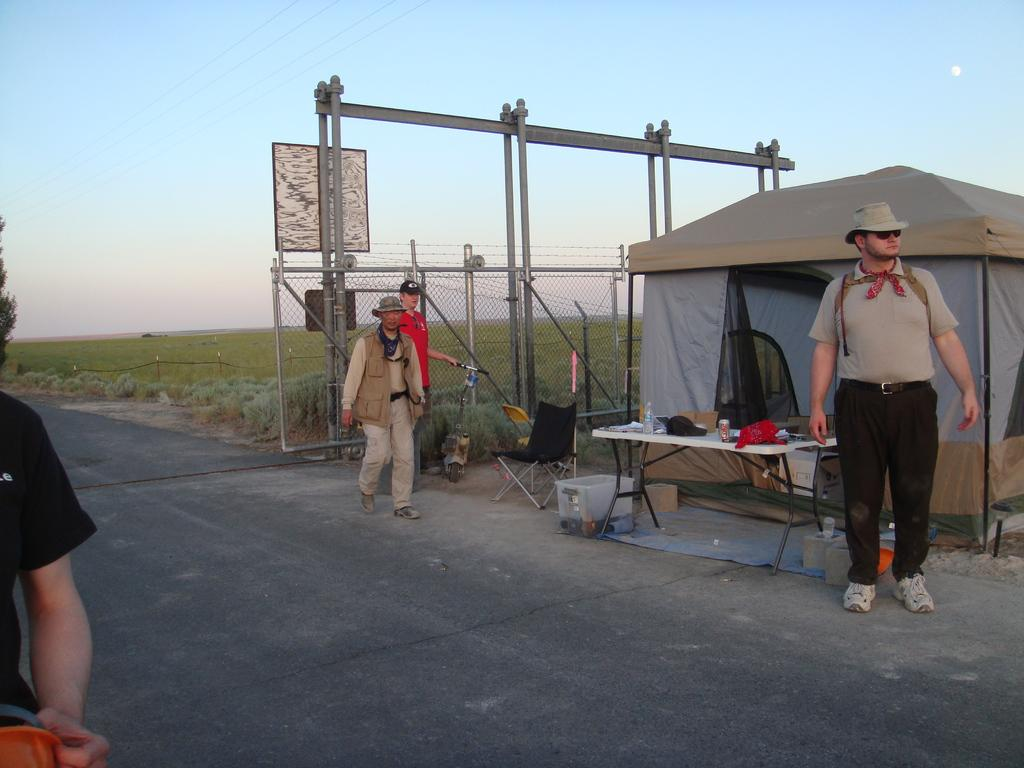What are the people in the image doing? The persons in the image are standing on the road. What can be seen in the background of the image? In the background, there is a tent, a table, a water bottle, fencing, plants, a tree, and the sky. How many objects can be seen in the background? There are eight objects visible in the background: a tent, a table, a water bottle, fencing, plants, a tree, and the sky. What type of calendar is hanging on the tree in the image? There is no calendar present in the image; it features a tree and other background elements. What color are the eyes of the person standing on the road? The image does not provide information about the color of anyone's eyes, as it focuses on the subjects' positions and the background elements. 